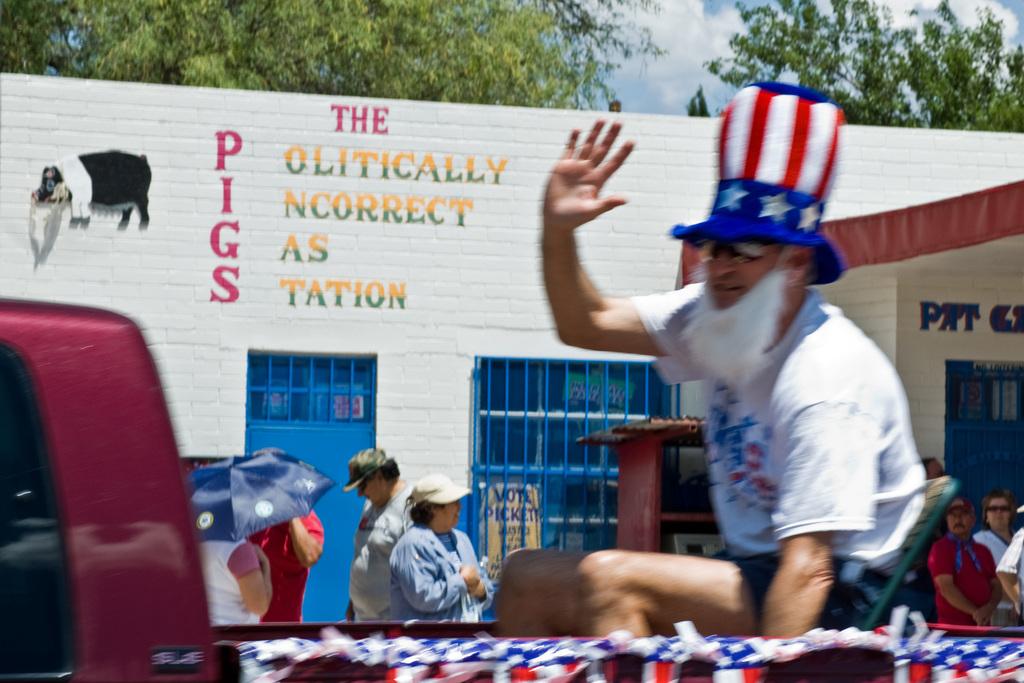What word is spelled downwards?
Offer a very short reply. Pigs. 